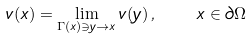Convert formula to latex. <formula><loc_0><loc_0><loc_500><loc_500>v ( x ) = \lim _ { \Gamma ( x ) \ni y \rightarrow x } v ( y ) \, , \quad x \in \partial \Omega</formula> 